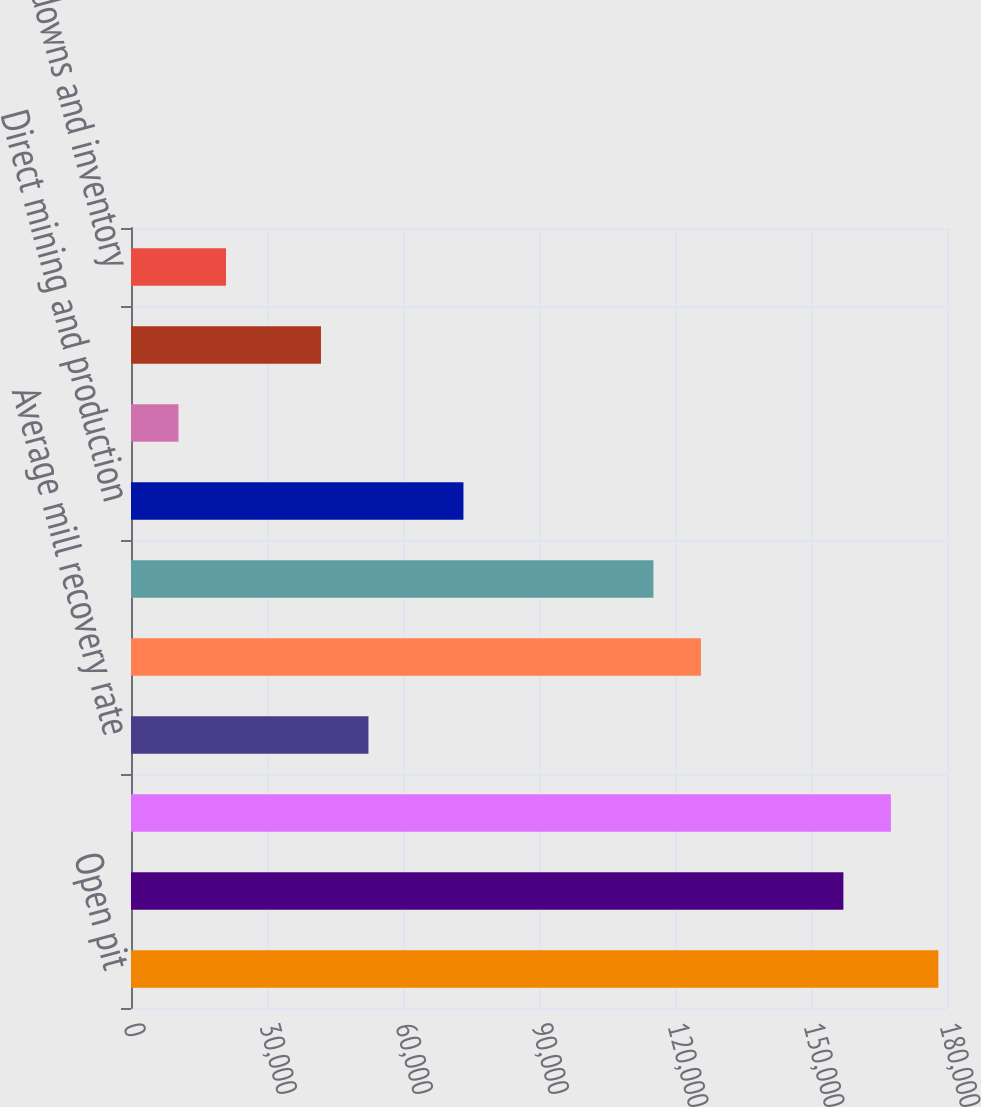<chart> <loc_0><loc_0><loc_500><loc_500><bar_chart><fcel>Open pit<fcel>Mill<fcel>Leach<fcel>Average mill recovery rate<fcel>Consolidated<fcel>Consolidated ounces sold (000)<fcel>Direct mining and production<fcel>By-product credits<fcel>Royalties and production taxes<fcel>Write-downs and inventory<nl><fcel>178097<fcel>157144<fcel>167621<fcel>52381.5<fcel>125716<fcel>115239<fcel>73334.1<fcel>10476.3<fcel>41905.2<fcel>20952.6<nl></chart> 